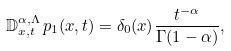<formula> <loc_0><loc_0><loc_500><loc_500>\mathbb { D } ^ { \alpha , \Lambda } _ { x , t } \, p _ { 1 } ( x , t ) = \delta _ { 0 } ( x ) \frac { t ^ { - \alpha } } { \Gamma ( 1 - \alpha ) } ,</formula> 